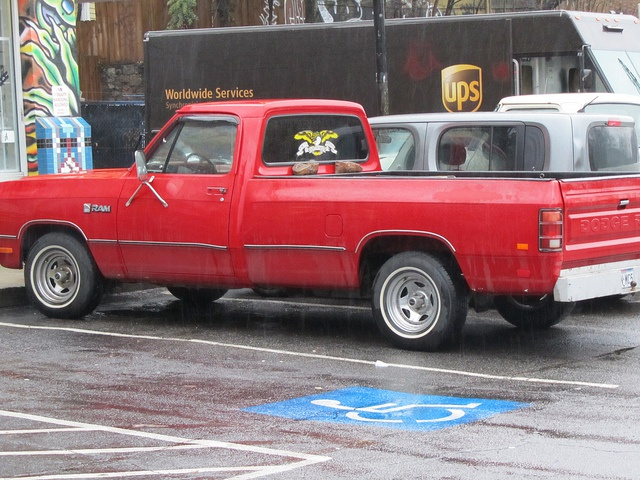Describe the objects in this image and their specific colors. I can see truck in darkgray, brown, black, and gray tones, truck in darkgray, gray, black, and lightgray tones, car in darkgray, gray, and lightgray tones, truck in darkgray, gray, and lightgray tones, and car in darkgray, white, and gray tones in this image. 